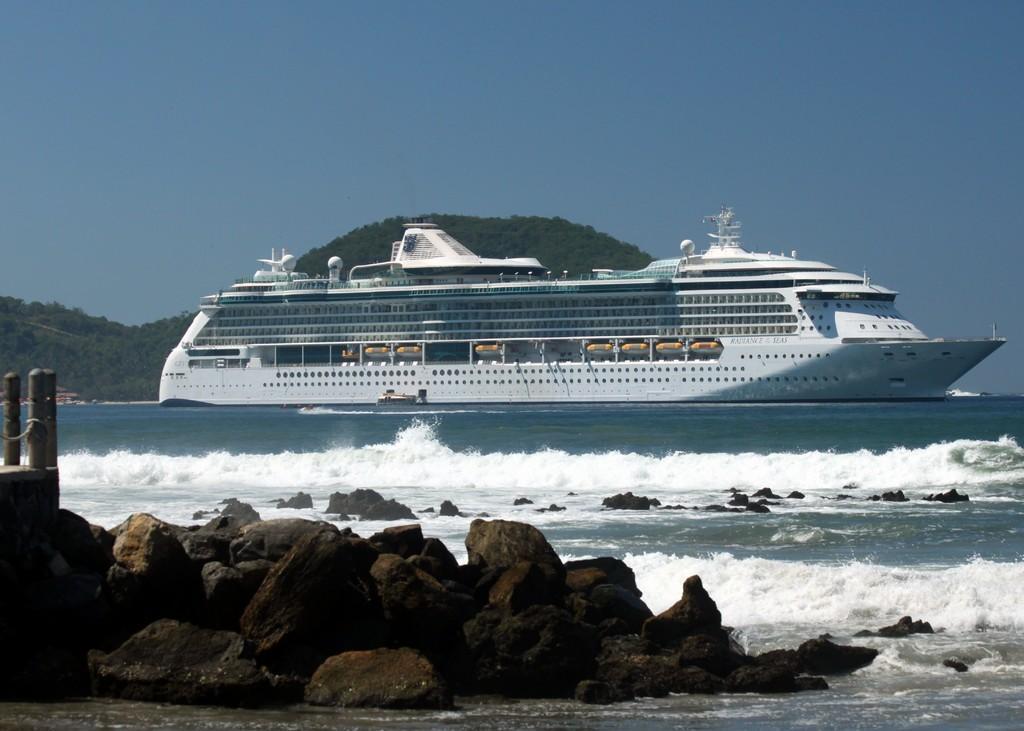Can you describe this image briefly? In this picture we can see few rocks and a ship in the water, in the background we can find hills and trees. 